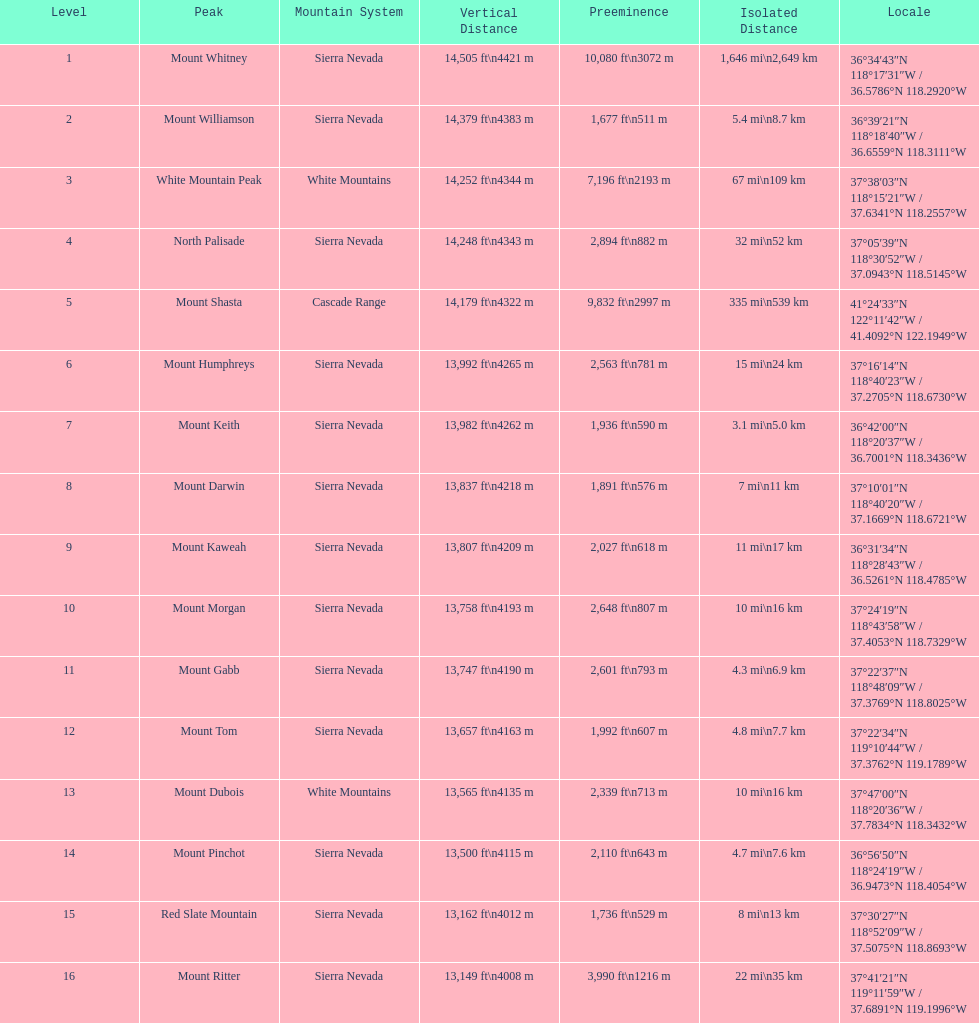What is the total elevation (in ft) of mount whitney? 14,505 ft. 